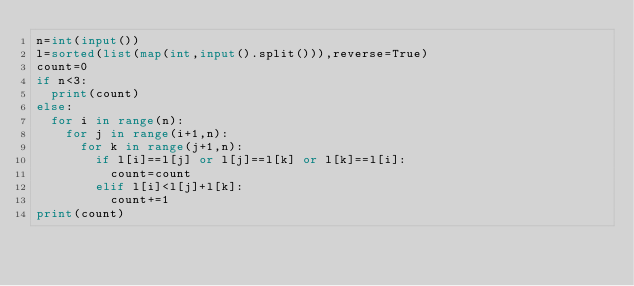Convert code to text. <code><loc_0><loc_0><loc_500><loc_500><_Python_>n=int(input())
l=sorted(list(map(int,input().split())),reverse=True)
count=0
if n<3:
  print(count)
else:
  for i in range(n):
    for j in range(i+1,n):
      for k in range(j+1,n):
        if l[i]==l[j] or l[j]==l[k] or l[k]==l[i]:
          count=count
        elif l[i]<l[j]+l[k]:
          count+=1
print(count)
</code> 